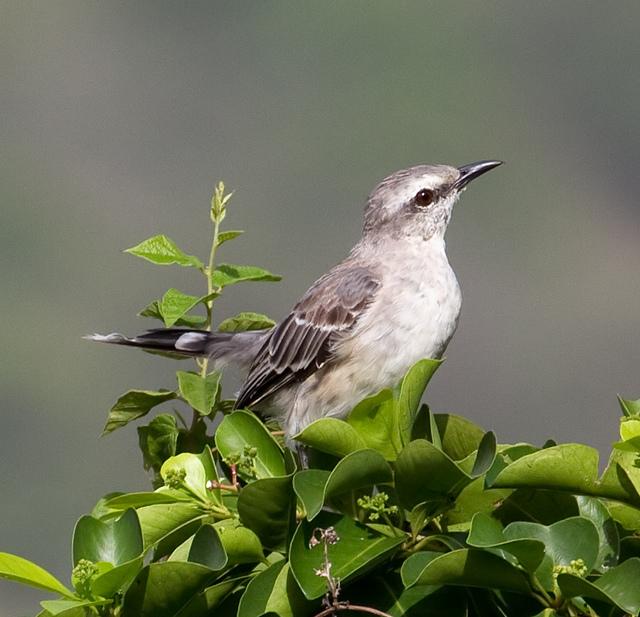What animal is this?
Concise answer only. Bird. Is this bird flightless?
Short answer required. No. Where is the bird?
Quick response, please. Tree. 